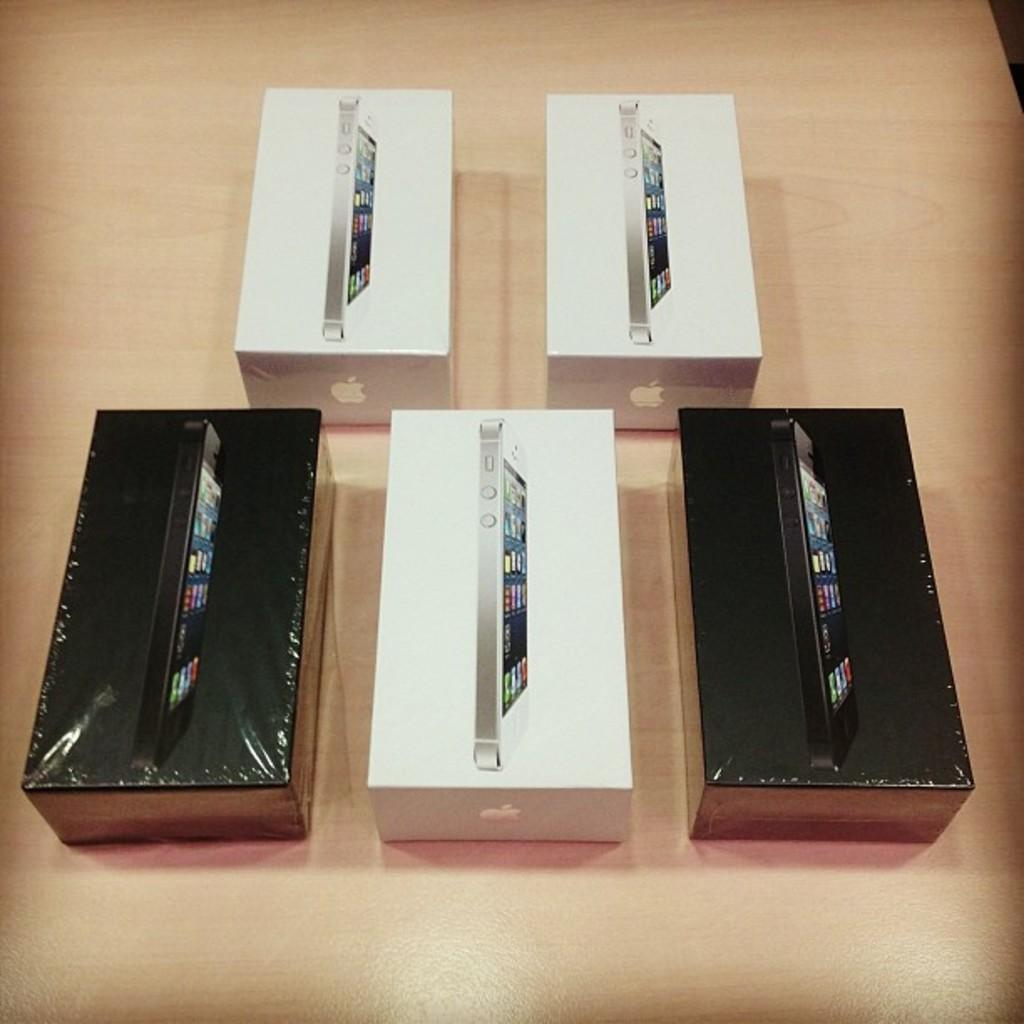What type of objects are visible in the image? There are mobile phone boxes in the image. What is the surface made of that the mobile phone boxes are placed on? The mobile phone boxes are on a wooden surface. What is the topic of the discussion taking place between the mobile phone boxes in the image? There is no discussion taking place between the mobile phone boxes in the image, as they are inanimate objects. 